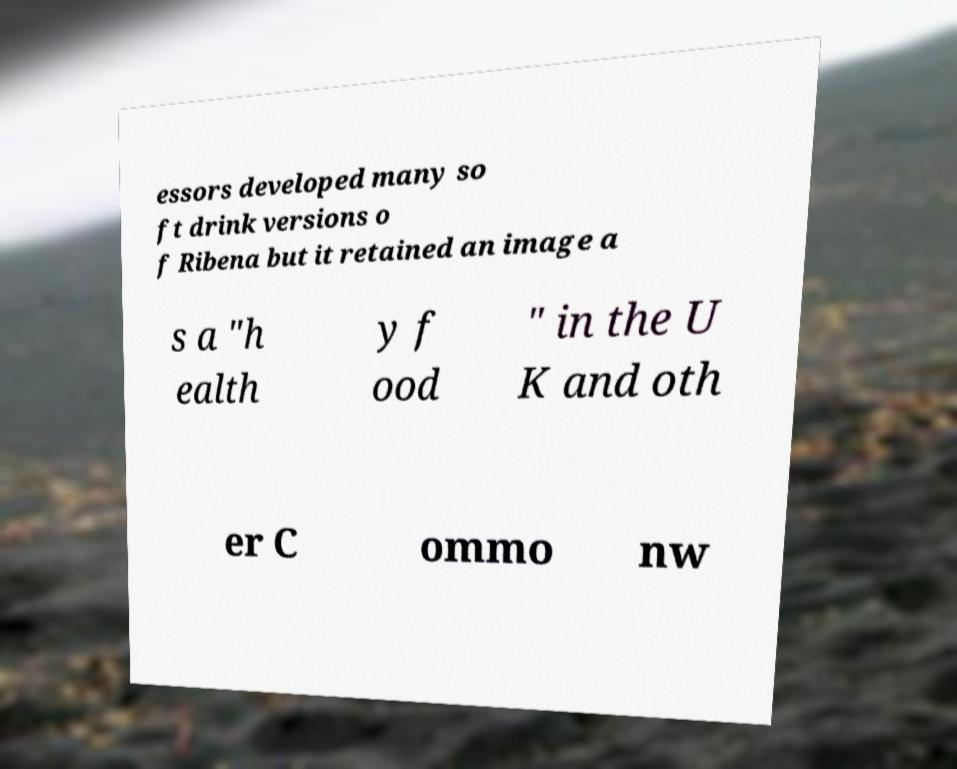Please identify and transcribe the text found in this image. essors developed many so ft drink versions o f Ribena but it retained an image a s a "h ealth y f ood " in the U K and oth er C ommo nw 